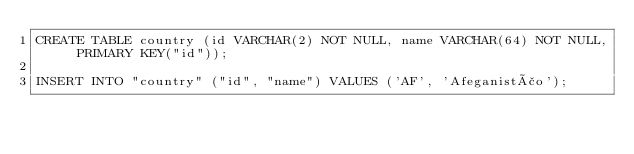<code> <loc_0><loc_0><loc_500><loc_500><_SQL_>CREATE TABLE country (id VARCHAR(2) NOT NULL, name VARCHAR(64) NOT NULL, PRIMARY KEY("id"));

INSERT INTO "country" ("id", "name") VALUES ('AF', 'Afeganistão');</code> 